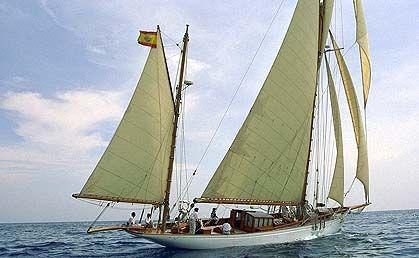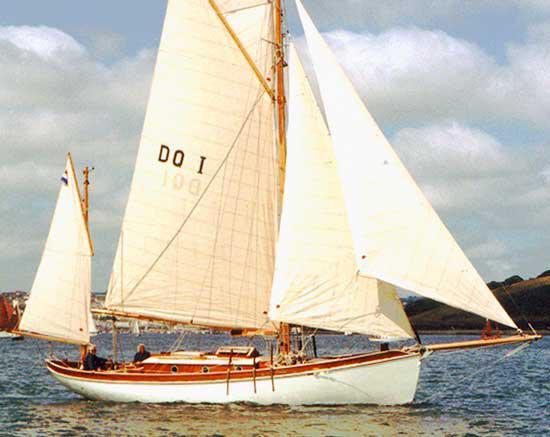The first image is the image on the left, the second image is the image on the right. For the images shown, is this caption "One image shows a boat with exactly three sails." true? Answer yes or no. No. The first image is the image on the left, the second image is the image on the right. Evaluate the accuracy of this statement regarding the images: "There is a landform visible behind the boat in one of the images.". Is it true? Answer yes or no. Yes. 